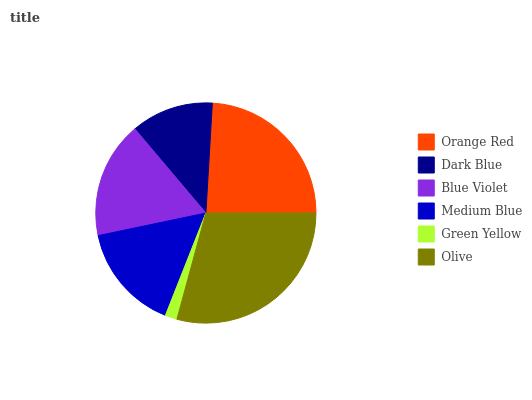Is Green Yellow the minimum?
Answer yes or no. Yes. Is Olive the maximum?
Answer yes or no. Yes. Is Dark Blue the minimum?
Answer yes or no. No. Is Dark Blue the maximum?
Answer yes or no. No. Is Orange Red greater than Dark Blue?
Answer yes or no. Yes. Is Dark Blue less than Orange Red?
Answer yes or no. Yes. Is Dark Blue greater than Orange Red?
Answer yes or no. No. Is Orange Red less than Dark Blue?
Answer yes or no. No. Is Blue Violet the high median?
Answer yes or no. Yes. Is Medium Blue the low median?
Answer yes or no. Yes. Is Dark Blue the high median?
Answer yes or no. No. Is Dark Blue the low median?
Answer yes or no. No. 